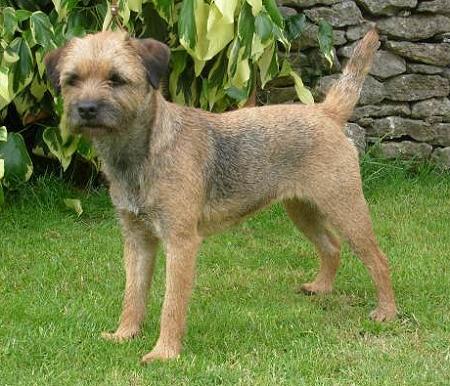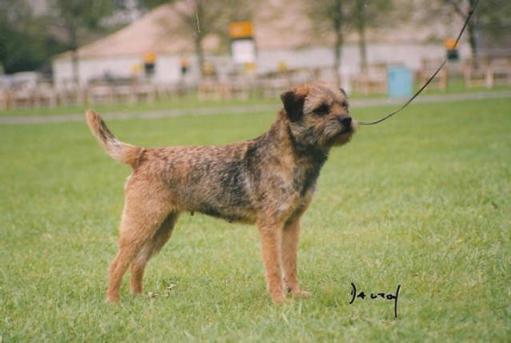The first image is the image on the left, the second image is the image on the right. Evaluate the accuracy of this statement regarding the images: "a dog has a leash on in the right image". Is it true? Answer yes or no. Yes. The first image is the image on the left, the second image is the image on the right. For the images shown, is this caption "In one of the images there are three dogs." true? Answer yes or no. No. 